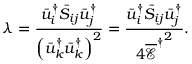Convert formula to latex. <formula><loc_0><loc_0><loc_500><loc_500>\lambda = \frac { { \bar { u } _ { i } ^ { \dag } { { \bar { S } } _ { i j } } \bar { u } _ { j } ^ { \dag } } } { { { { \left ( { \bar { u } _ { k } ^ { \dag } \bar { u } _ { k } ^ { \dag } } \right ) } ^ { 2 } } } } = \frac { { \bar { u } _ { i } ^ { \dag } { { \bar { S } } _ { i j } } \bar { u } _ { j } ^ { \dag } } } { { 4 { { \overline { \mathcal { E } } } ^ { \dag } } ^ { 2 } } } .</formula> 